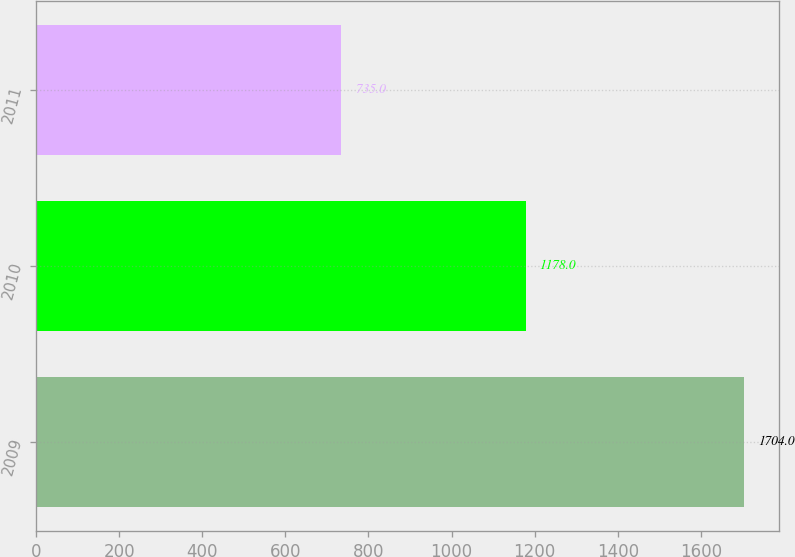Convert chart. <chart><loc_0><loc_0><loc_500><loc_500><bar_chart><fcel>2009<fcel>2010<fcel>2011<nl><fcel>1704<fcel>1178<fcel>735<nl></chart> 